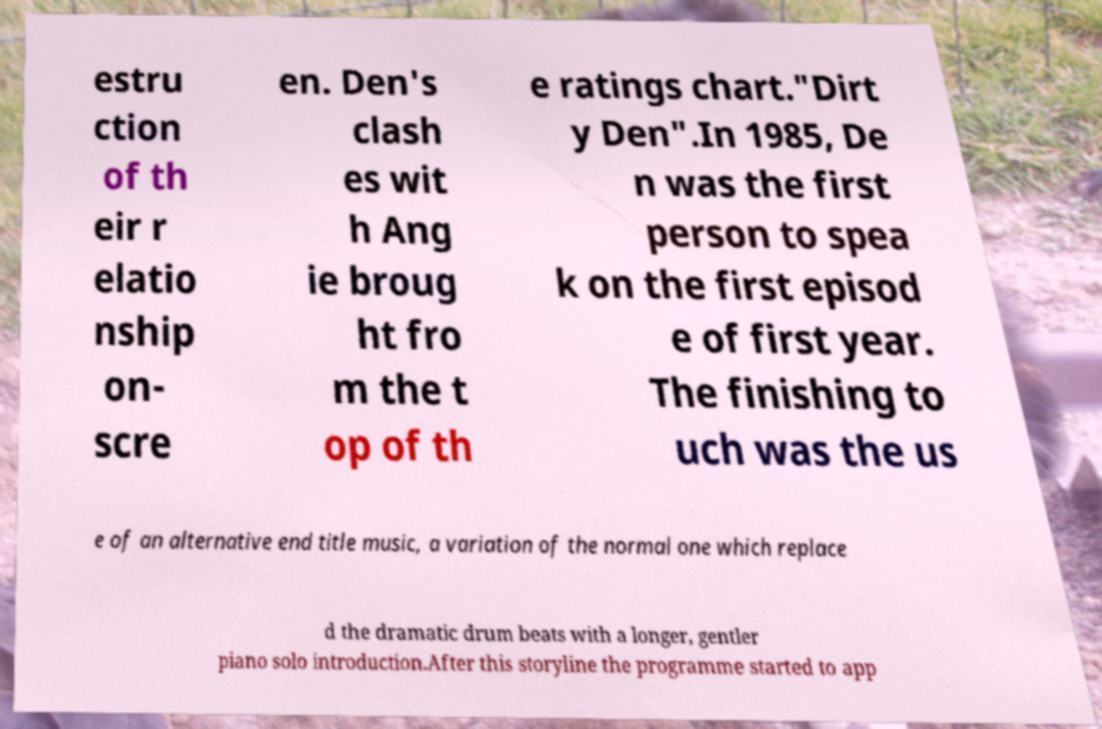Please identify and transcribe the text found in this image. estru ction of th eir r elatio nship on- scre en. Den's clash es wit h Ang ie broug ht fro m the t op of th e ratings chart."Dirt y Den".In 1985, De n was the first person to spea k on the first episod e of first year. The finishing to uch was the us e of an alternative end title music, a variation of the normal one which replace d the dramatic drum beats with a longer, gentler piano solo introduction.After this storyline the programme started to app 